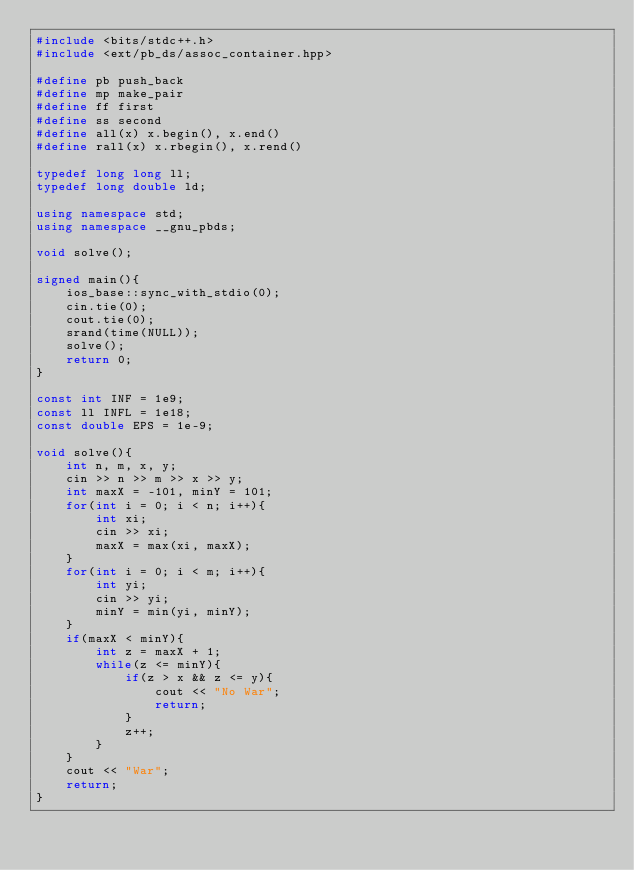Convert code to text. <code><loc_0><loc_0><loc_500><loc_500><_C++_>#include <bits/stdc++.h>
#include <ext/pb_ds/assoc_container.hpp>

#define pb push_back
#define mp make_pair
#define ff first
#define ss second
#define all(x) x.begin(), x.end()
#define rall(x) x.rbegin(), x.rend()

typedef long long ll;
typedef long double ld;

using namespace std;
using namespace __gnu_pbds;

void solve();

signed main(){
    ios_base::sync_with_stdio(0);
    cin.tie(0);
    cout.tie(0);
    srand(time(NULL));
    solve();
    return 0;
}

const int INF = 1e9;
const ll INFL = 1e18;
const double EPS = 1e-9;

void solve(){
    int n, m, x, y;
    cin >> n >> m >> x >> y;
    int maxX = -101, minY = 101;
    for(int i = 0; i < n; i++){
        int xi;
        cin >> xi;
        maxX = max(xi, maxX);
    }
    for(int i = 0; i < m; i++){
        int yi;
        cin >> yi;
        minY = min(yi, minY);
    }
    if(maxX < minY){
        int z = maxX + 1;
        while(z <= minY){
            if(z > x && z <= y){
                cout << "No War";
                return;
            }
            z++;
        }
    }
    cout << "War";
    return;
}
</code> 